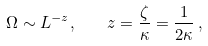<formula> <loc_0><loc_0><loc_500><loc_500>\Omega \sim L ^ { - z } , \quad z = \frac { \zeta } { \kappa } = \frac { 1 } { 2 \kappa } \, ,</formula> 